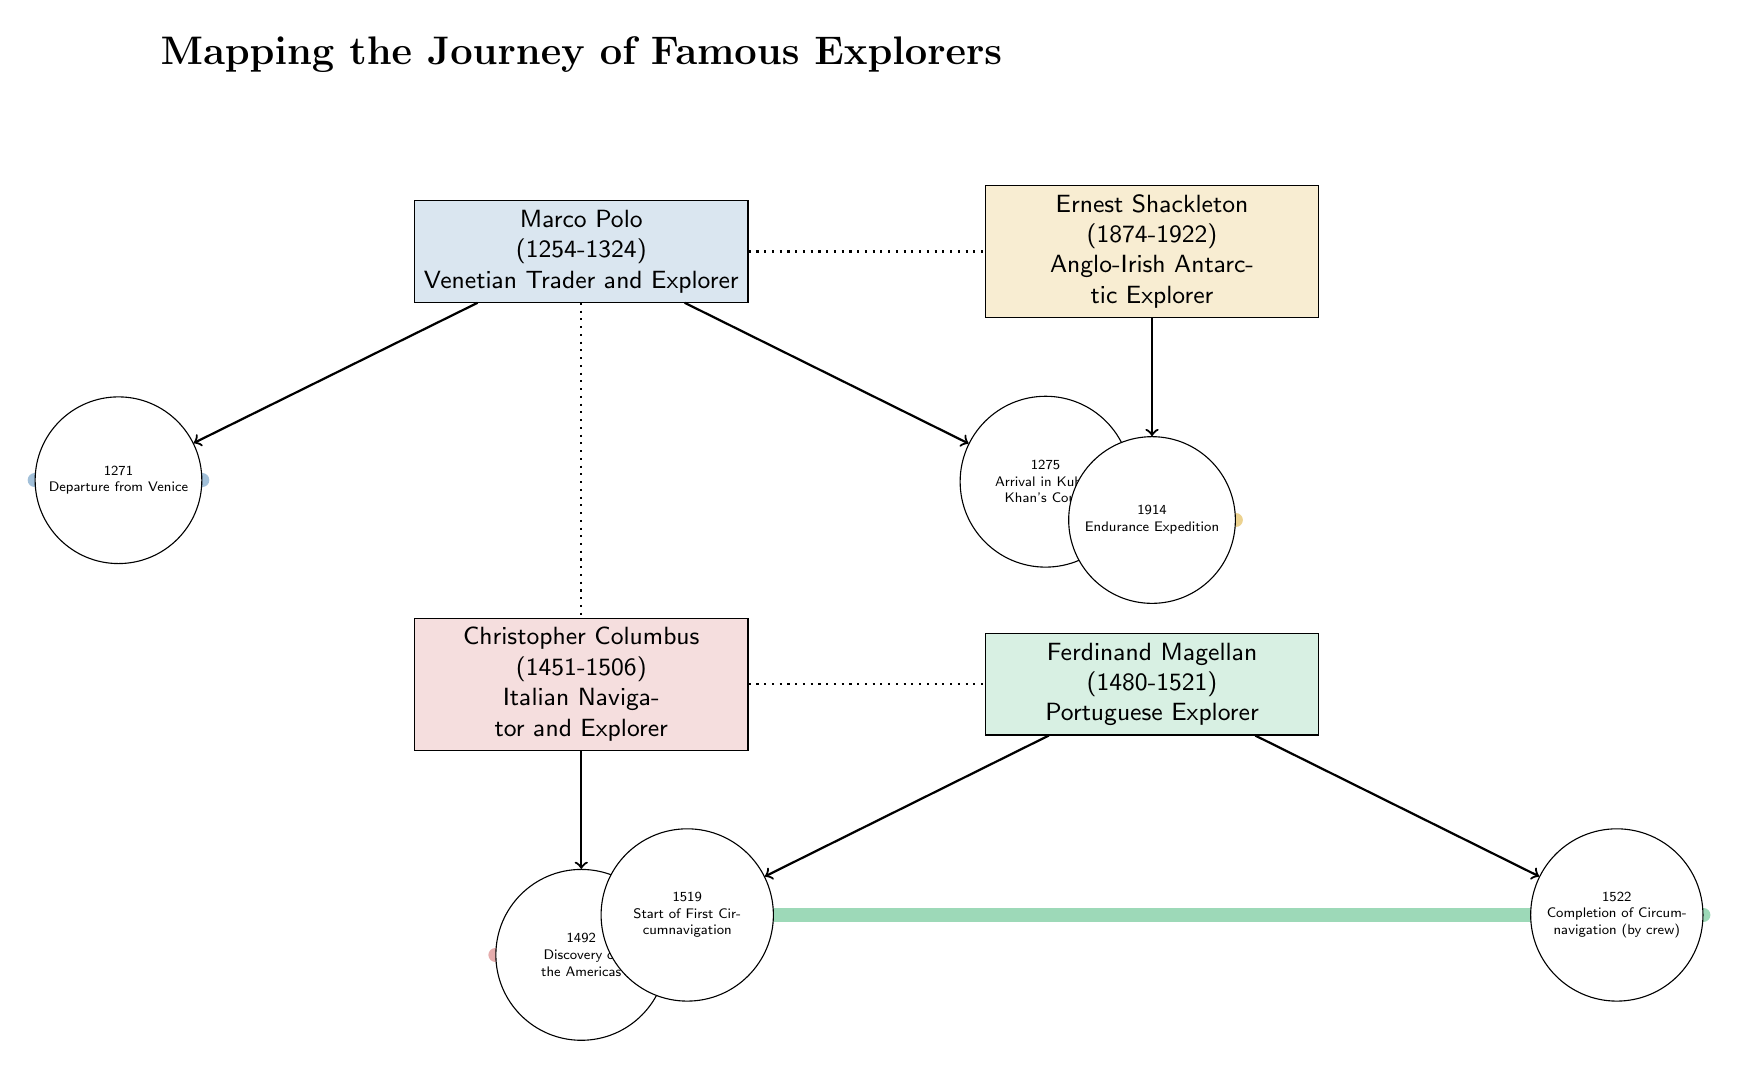What is the birth year of Marco Polo? The diagram states Marco Polo's lifespan as 1254-1324, therefore, he was born in 1254.
Answer: 1254 How many explorers are shown in the diagram? The diagram displays four explorers: Marco Polo, Christopher Columbus, Ferdinand Magellan, and Ernest Shackleton. Counting these names gives a total of four.
Answer: 4 What significant event occurred in 1492 according to the diagram? The diagram indicates that the event associated with Christopher Columbus in 1492 is the discovery of the Americas. This specific detail can be found directly linked to Columbus's node.
Answer: Discovery of the Americas Between which two explorers is there a dotted line? The dotted line connects the time periods of Marco Polo and Christopher Columbus, indicating a relationship or chronological sequence between their explorations.
Answer: Marco Polo and Christopher Columbus What was the achievement of Ferdinand Magellan's crew in 1522? The diagram notes that the completion of circumnavigation by Magellan's crew occurred in 1522, highlighting this monumental achievement.
Answer: Completion of Circumnavigation (by crew) Which explorer’s expedition is highlighted in 1914? Ernest Shackleton’s Endurance Expedition is noted in the diagram for the year 1914, making it the event associated with this explorer.
Answer: Endurance Expedition How many years did Marco Polo's exploration span from departure to arrival at Kublai Khan's Court? Marco Polo departed in 1271 and arrived in the court in 1275; the difference between these years shows his exploration spanned 4 years.
Answer: 4 years What color is used to represent Christopher Columbus? The diagram uses a light red fill (specified as explorer2) to represent Columbus, indicating a distinct color scheme for each explorer.
Answer: Light red Which explorer is listed last in terms of the timeline of events? Ernest Shackleton is the last explorer in the timeline, with his notable expedition marked in 1914. Since the other events occurred earlier, he concludes the order shown.
Answer: Ernest Shackleton 